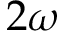Convert formula to latex. <formula><loc_0><loc_0><loc_500><loc_500>2 \omega</formula> 